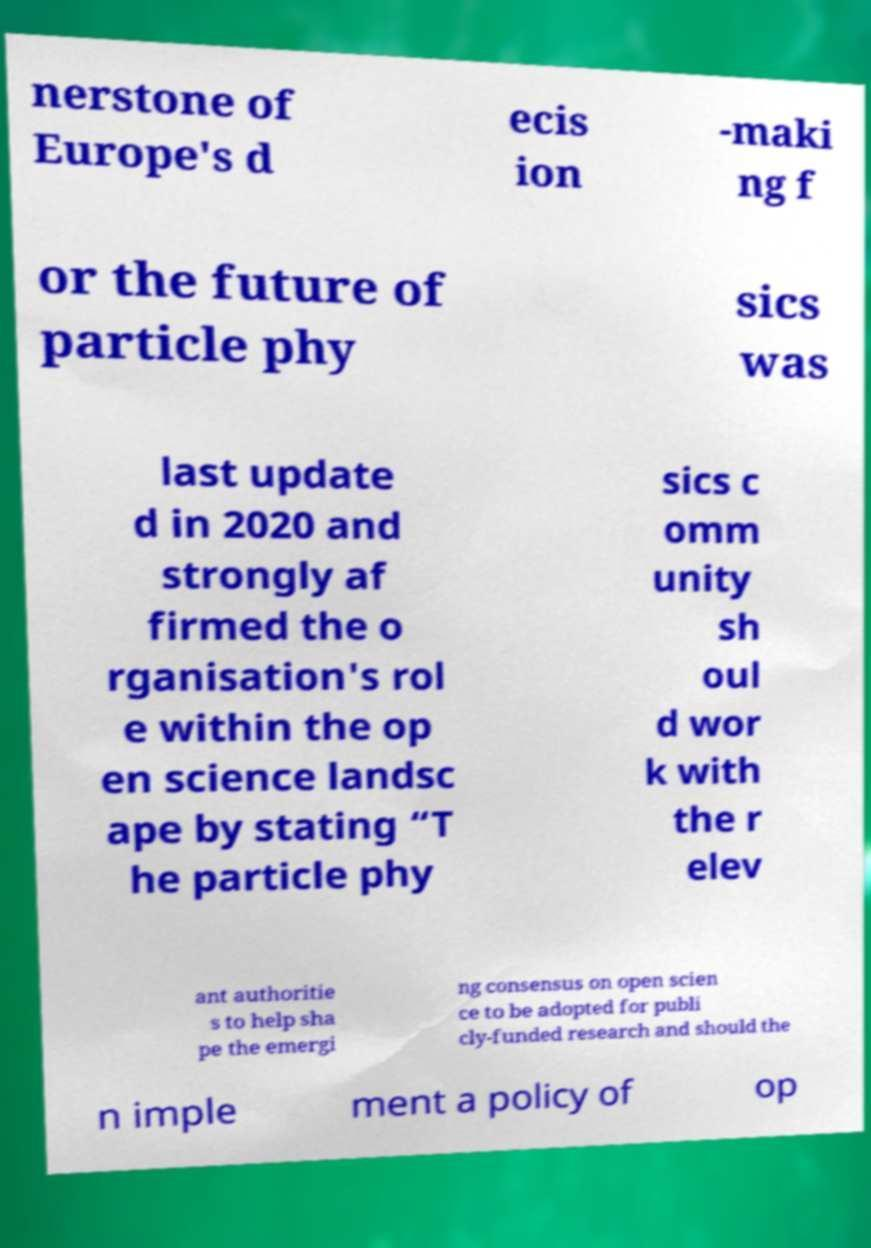Could you extract and type out the text from this image? nerstone of Europe's d ecis ion -maki ng f or the future of particle phy sics was last update d in 2020 and strongly af firmed the o rganisation's rol e within the op en science landsc ape by stating “T he particle phy sics c omm unity sh oul d wor k with the r elev ant authoritie s to help sha pe the emergi ng consensus on open scien ce to be adopted for publi cly-funded research and should the n imple ment a policy of op 